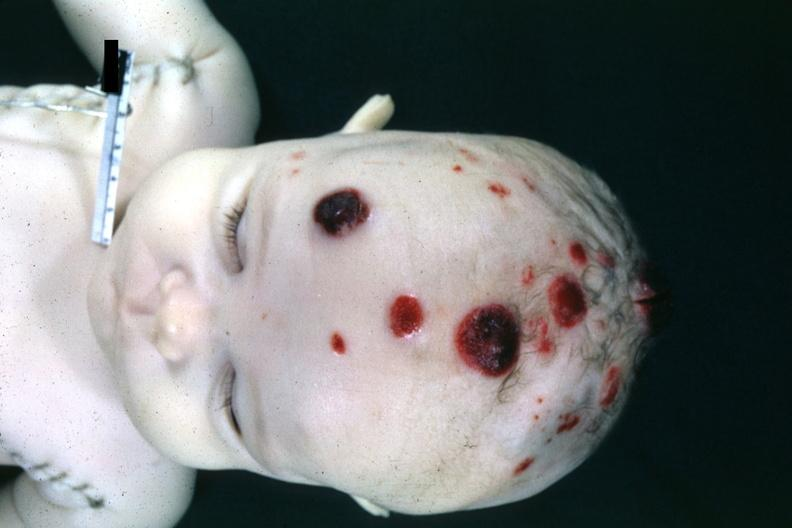re fixed tissue lateral view of vertebral bodies with many in this file?
Answer the question using a single word or phrase. No 